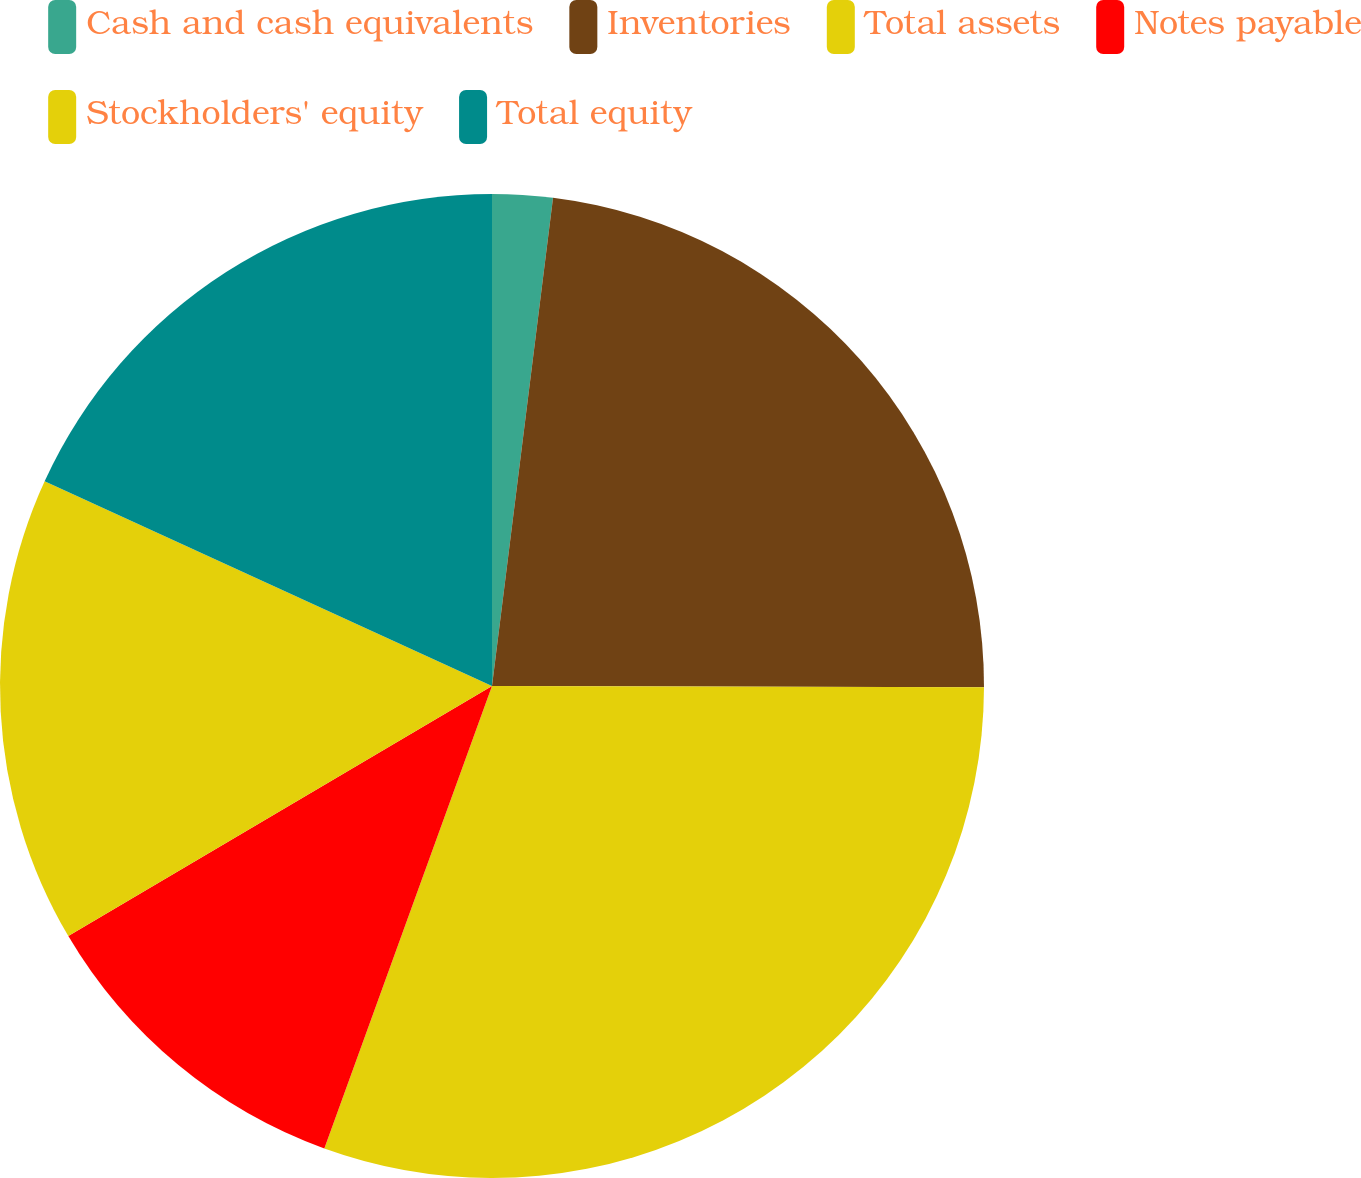Convert chart to OTSL. <chart><loc_0><loc_0><loc_500><loc_500><pie_chart><fcel>Cash and cash equivalents<fcel>Inventories<fcel>Total assets<fcel>Notes payable<fcel>Stockholders' equity<fcel>Total equity<nl><fcel>1.98%<fcel>23.06%<fcel>30.5%<fcel>10.98%<fcel>15.32%<fcel>18.17%<nl></chart> 